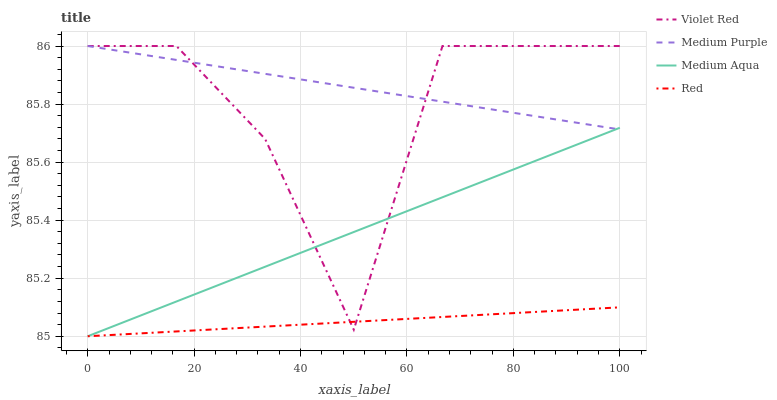Does Red have the minimum area under the curve?
Answer yes or no. Yes. Does Medium Purple have the maximum area under the curve?
Answer yes or no. Yes. Does Violet Red have the minimum area under the curve?
Answer yes or no. No. Does Violet Red have the maximum area under the curve?
Answer yes or no. No. Is Red the smoothest?
Answer yes or no. Yes. Is Violet Red the roughest?
Answer yes or no. Yes. Is Medium Aqua the smoothest?
Answer yes or no. No. Is Medium Aqua the roughest?
Answer yes or no. No. Does Medium Aqua have the lowest value?
Answer yes or no. Yes. Does Violet Red have the lowest value?
Answer yes or no. No. Does Violet Red have the highest value?
Answer yes or no. Yes. Does Medium Aqua have the highest value?
Answer yes or no. No. Is Red less than Medium Purple?
Answer yes or no. Yes. Is Medium Purple greater than Red?
Answer yes or no. Yes. Does Medium Aqua intersect Medium Purple?
Answer yes or no. Yes. Is Medium Aqua less than Medium Purple?
Answer yes or no. No. Is Medium Aqua greater than Medium Purple?
Answer yes or no. No. Does Red intersect Medium Purple?
Answer yes or no. No. 